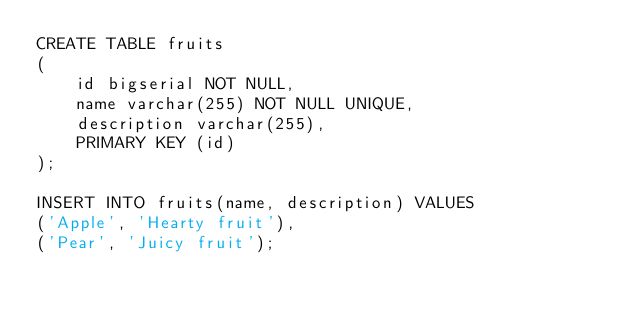<code> <loc_0><loc_0><loc_500><loc_500><_SQL_>CREATE TABLE fruits
(
	id bigserial NOT NULL,
	name varchar(255) NOT NULL UNIQUE,
	description varchar(255),
	PRIMARY KEY (id)
);

INSERT INTO fruits(name, description) VALUES
('Apple', 'Hearty fruit'),
('Pear', 'Juicy fruit');
</code> 